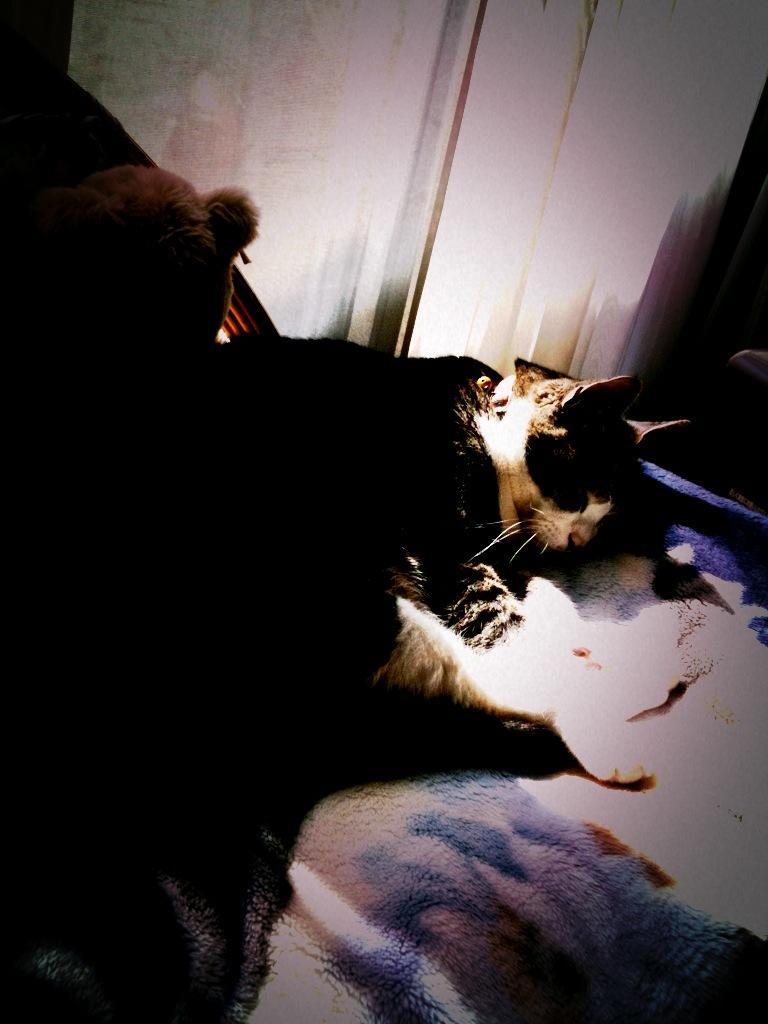What type of animal is present in the image? There is a cat in the image. What other object can be seen in the image? There is a teddy in the image. What type of butter can be seen on the mailbox in the image? There is no butter or mailbox present in the image. How many trees are visible in the image? There are no trees visible in the image. 